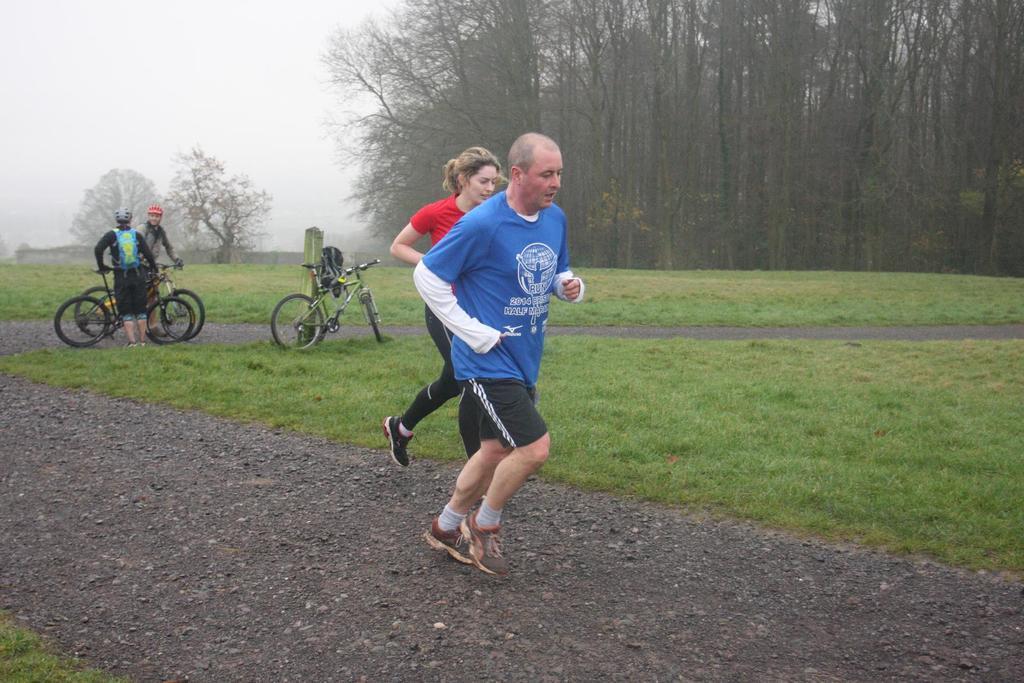Describe this image in one or two sentences. This image consists of four persons. In the front, two persons are running. At the bottom, there is a road. And we can see the green grass on the ground. In the background, we can see three cycles. On the right, there are trees. At the top, there is the sky. 